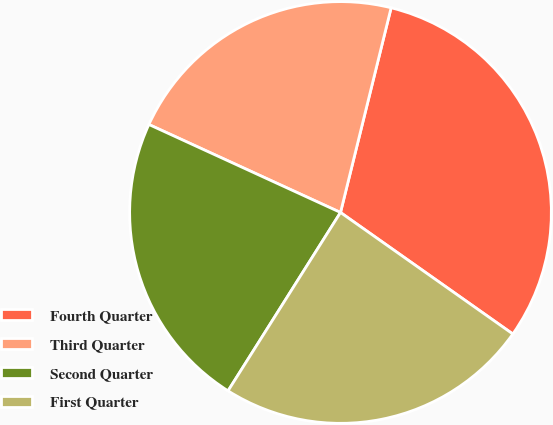<chart> <loc_0><loc_0><loc_500><loc_500><pie_chart><fcel>Fourth Quarter<fcel>Third Quarter<fcel>Second Quarter<fcel>First Quarter<nl><fcel>30.92%<fcel>22.01%<fcel>22.9%<fcel>24.18%<nl></chart> 